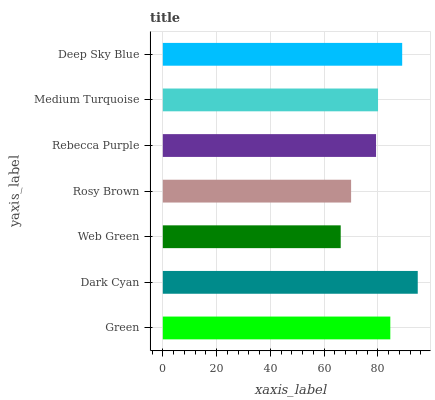Is Web Green the minimum?
Answer yes or no. Yes. Is Dark Cyan the maximum?
Answer yes or no. Yes. Is Dark Cyan the minimum?
Answer yes or no. No. Is Web Green the maximum?
Answer yes or no. No. Is Dark Cyan greater than Web Green?
Answer yes or no. Yes. Is Web Green less than Dark Cyan?
Answer yes or no. Yes. Is Web Green greater than Dark Cyan?
Answer yes or no. No. Is Dark Cyan less than Web Green?
Answer yes or no. No. Is Medium Turquoise the high median?
Answer yes or no. Yes. Is Medium Turquoise the low median?
Answer yes or no. Yes. Is Rebecca Purple the high median?
Answer yes or no. No. Is Rosy Brown the low median?
Answer yes or no. No. 